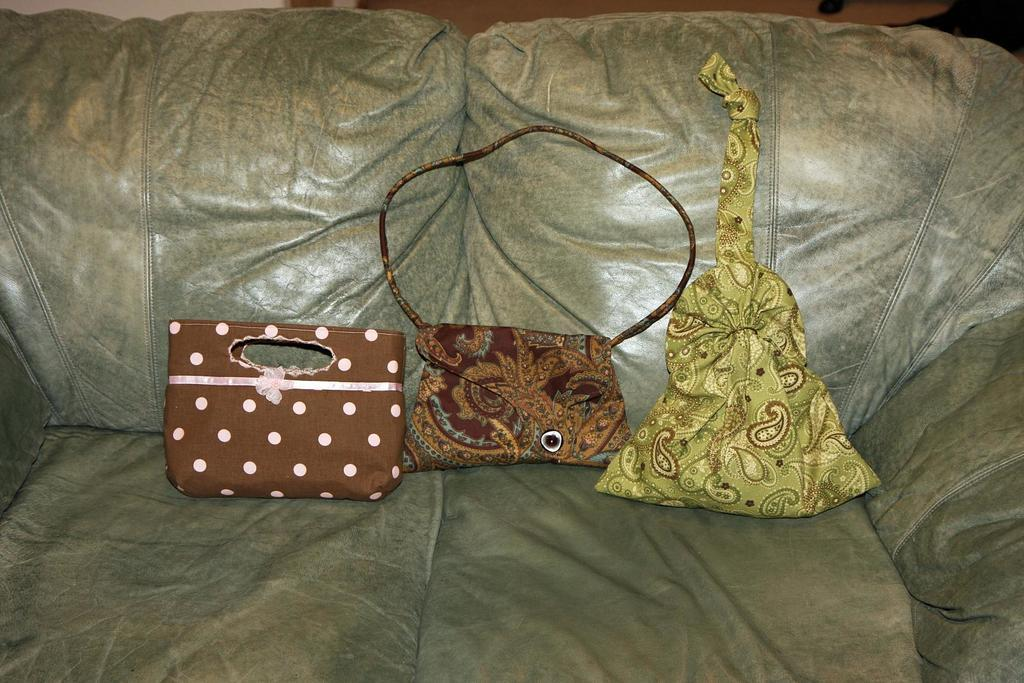What objects are on the couch in the image? There are three bags on a couch. What type of grain is being stored in the bags on the couch? There is no indication of any grain in the image; it only shows three bags on a couch. 